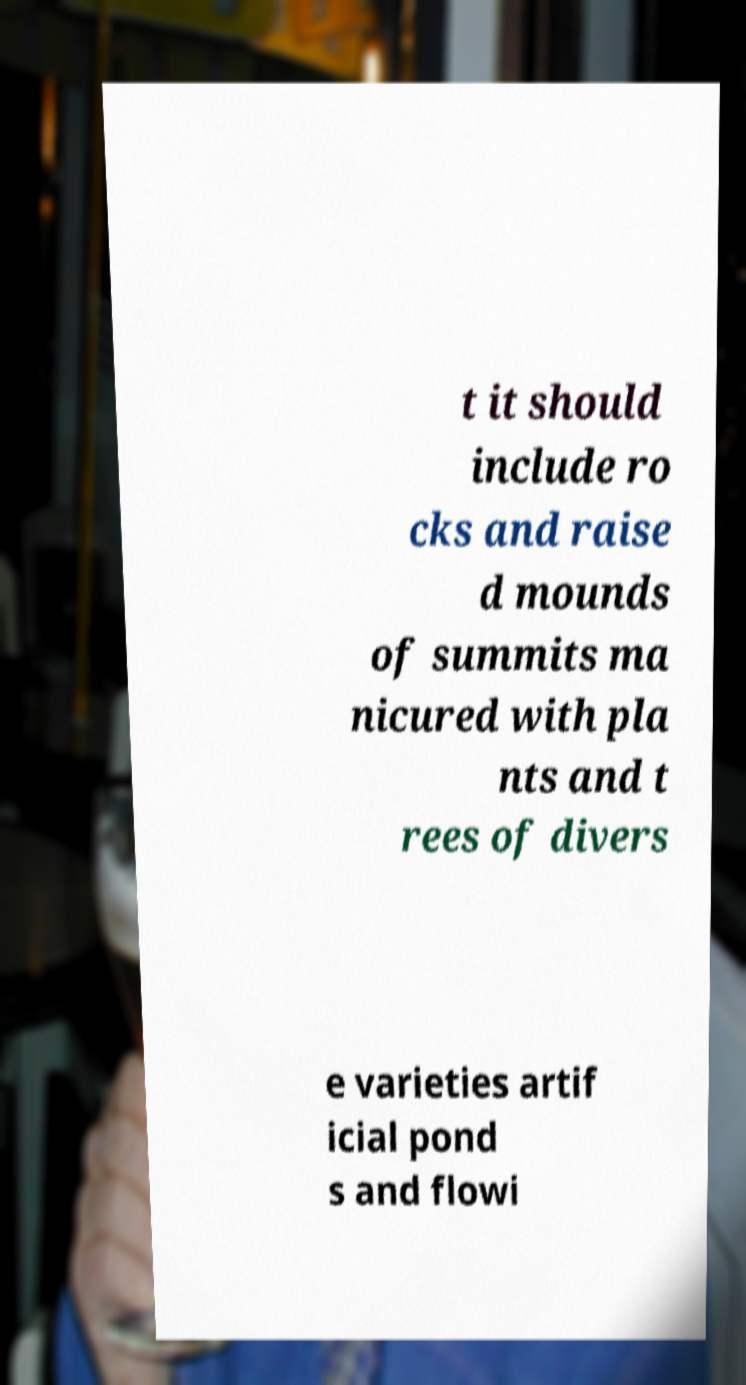For documentation purposes, I need the text within this image transcribed. Could you provide that? t it should include ro cks and raise d mounds of summits ma nicured with pla nts and t rees of divers e varieties artif icial pond s and flowi 